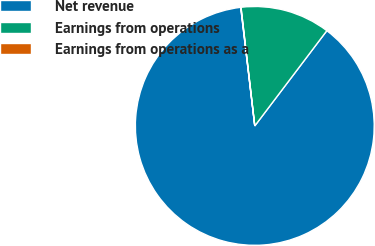<chart> <loc_0><loc_0><loc_500><loc_500><pie_chart><fcel>Net revenue<fcel>Earnings from operations<fcel>Earnings from operations as a<nl><fcel>87.81%<fcel>12.15%<fcel>0.04%<nl></chart> 